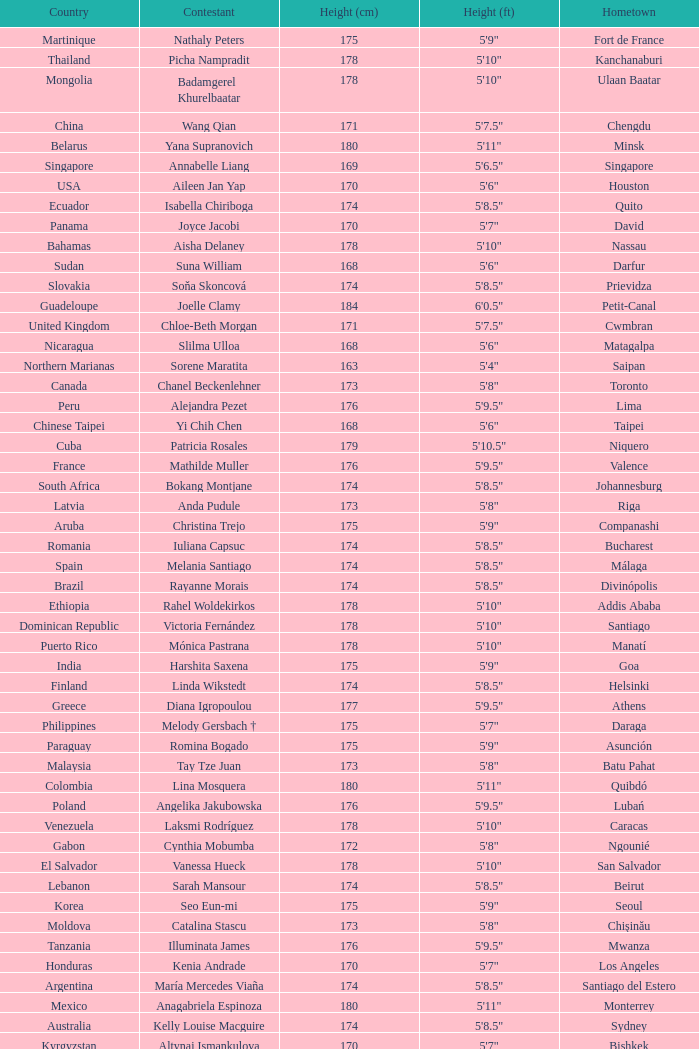What is the hometown of the player from Indonesia? Denpasar. 